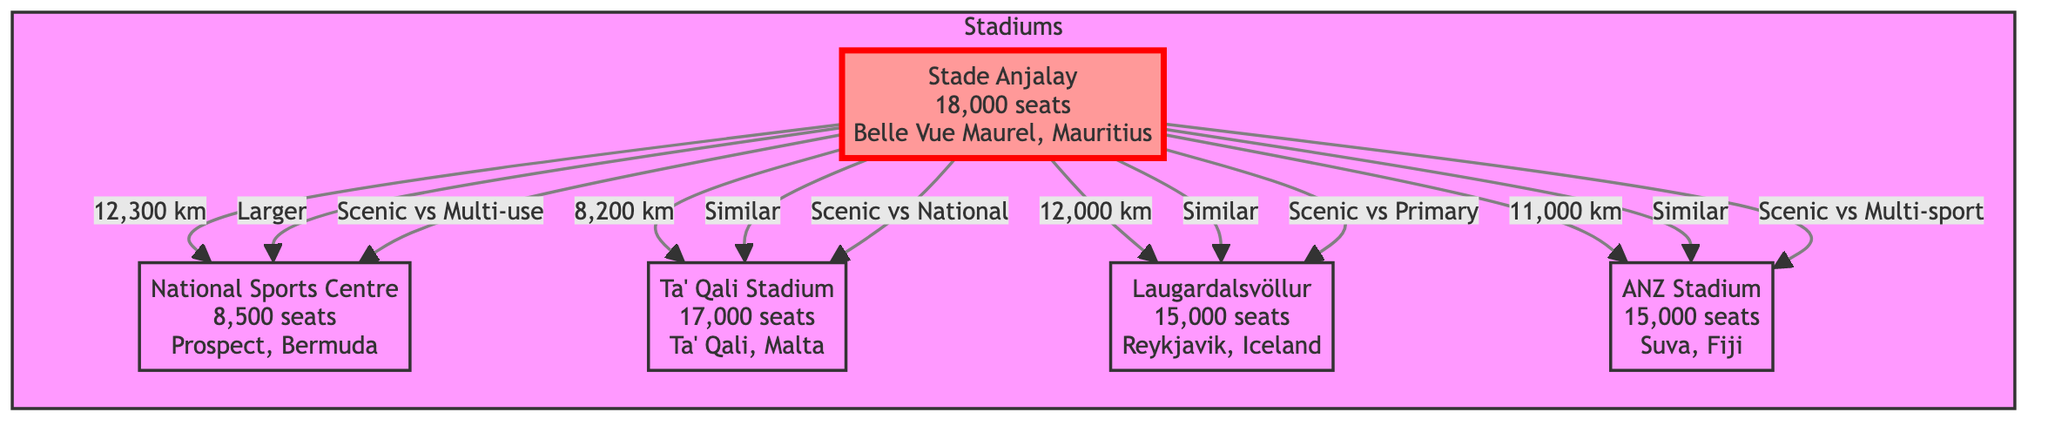What is the seating capacity of Stade Anjalay? The diagram explicitly states that Stade Anjalay has a seating capacity of 18,000 seats. This information is read directly from the relevant node in the diagram.
Answer: 18,000 seats Which stadium is located in Iceland? The diagram shows Laugardalsvöllur as the stadium located in Reykjavik, Iceland. This information is extracted from the node that represents Laugardalsvöllur.
Answer: Laugardalsvöllur What is the relationship between Stade Anjalay and National Sports Centre? The relationship is clearly marked as "Larger" in the diagram, indicating that Stade Anjalay has a larger seating capacity compared to National Sports Centre. This can be determined by the directional arrow and the accompanying label between the two nodes.
Answer: Larger How far is Stade Anjalay from Ta' Qali Stadium? The diagram specifies a distance of 8,200 km connecting Stade Anjalay to Ta' Qali Stadium, which is indicated beside the connecting arrow.
Answer: 8,200 km What type of stadium is Ta' Qali Stadium compared to Stade Anjalay? The diagram denotes Ta' Qali Stadium as "Similar" to Stade Anjalay, indicating a similarity in some aspect, likely seating capacity or function. This information comes from the relationship arrow labeled "Similar".
Answer: Similar How many nodes are there representing stadiums in the diagram? The diagram displays a total of five nodes, each representing a different stadium. This can be counted directly from the diagram, confirming that five distinct stadiums are mentioned.
Answer: 5 What are the unique features of the stadium in Bermuda? The diagram indicates that the unique feature of the National Sports Centre in Bermuda is "Multi-use". This is shown on the line connecting it back to Stade Anjalay, where its characteristic is noted.
Answer: Multi-use What are the total seating capacities of the stadiums displayed in the diagram? By examining each stadium's seating capacity as listed in the diagram, the total can be calculated by adding 18,000 (Stade Anjalay) + 8,500 (National Sports Centre) + 17,000 (Ta' Qali Stadium) + 15,000 (Laugardalsvöllur) + 15,000 (ANZ Stadium), leading to a comprehensive total.
Answer: 73,500 seats Which stadium has a seating capacity closest to ANZ Stadium? The diagram shows that both Laugardalsvöllur and ANZ Stadium have a seating capacity of 15,000 seats each, making the two stadiums equivalent in size. The connections and values confirm this information directly.
Answer: Laugardalsvöllur 